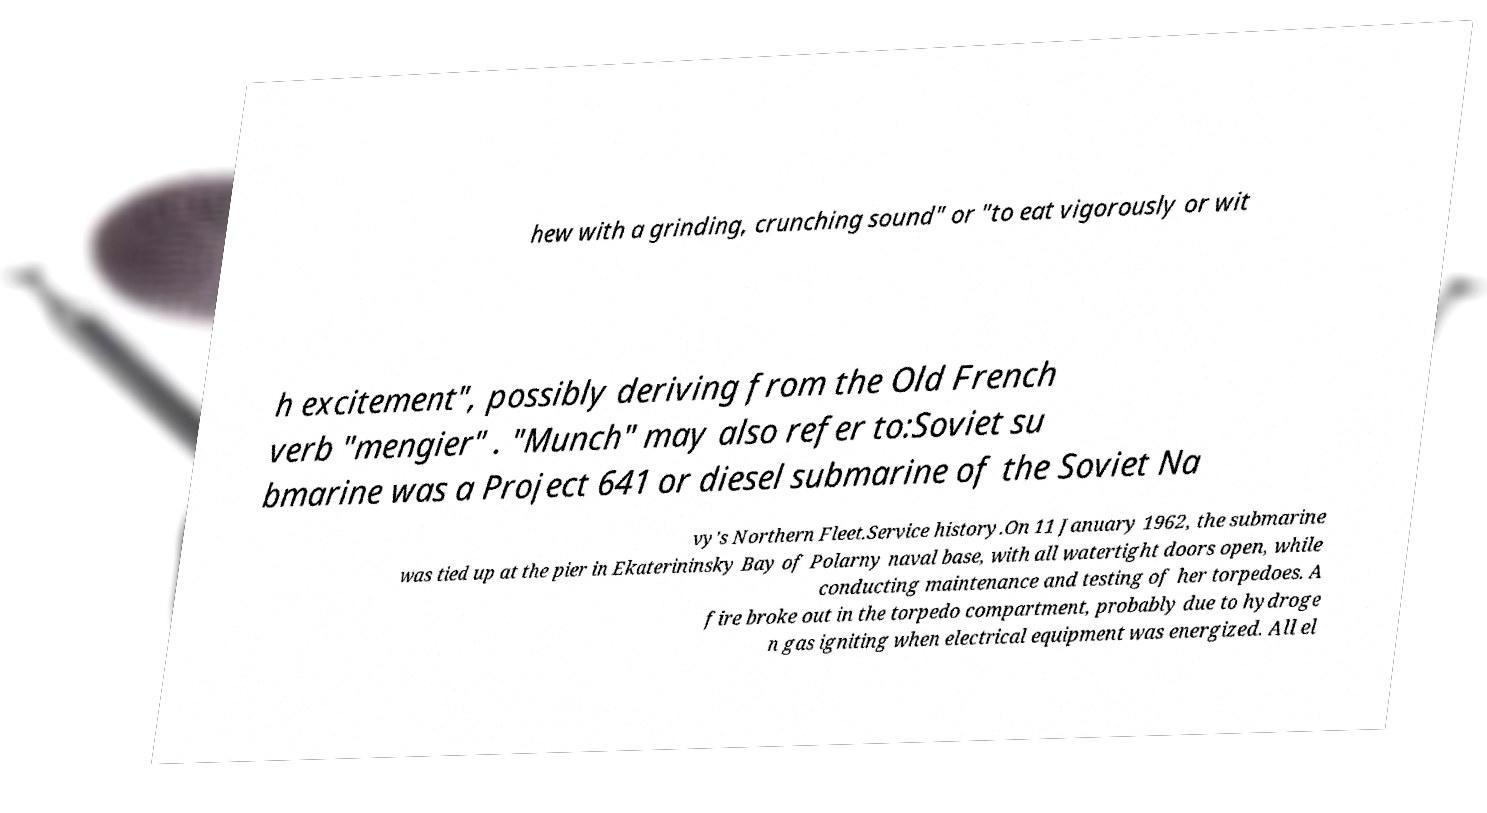Can you accurately transcribe the text from the provided image for me? hew with a grinding, crunching sound" or "to eat vigorously or wit h excitement", possibly deriving from the Old French verb "mengier" . "Munch" may also refer to:Soviet su bmarine was a Project 641 or diesel submarine of the Soviet Na vy's Northern Fleet.Service history.On 11 January 1962, the submarine was tied up at the pier in Ekaterininsky Bay of Polarny naval base, with all watertight doors open, while conducting maintenance and testing of her torpedoes. A fire broke out in the torpedo compartment, probably due to hydroge n gas igniting when electrical equipment was energized. All el 